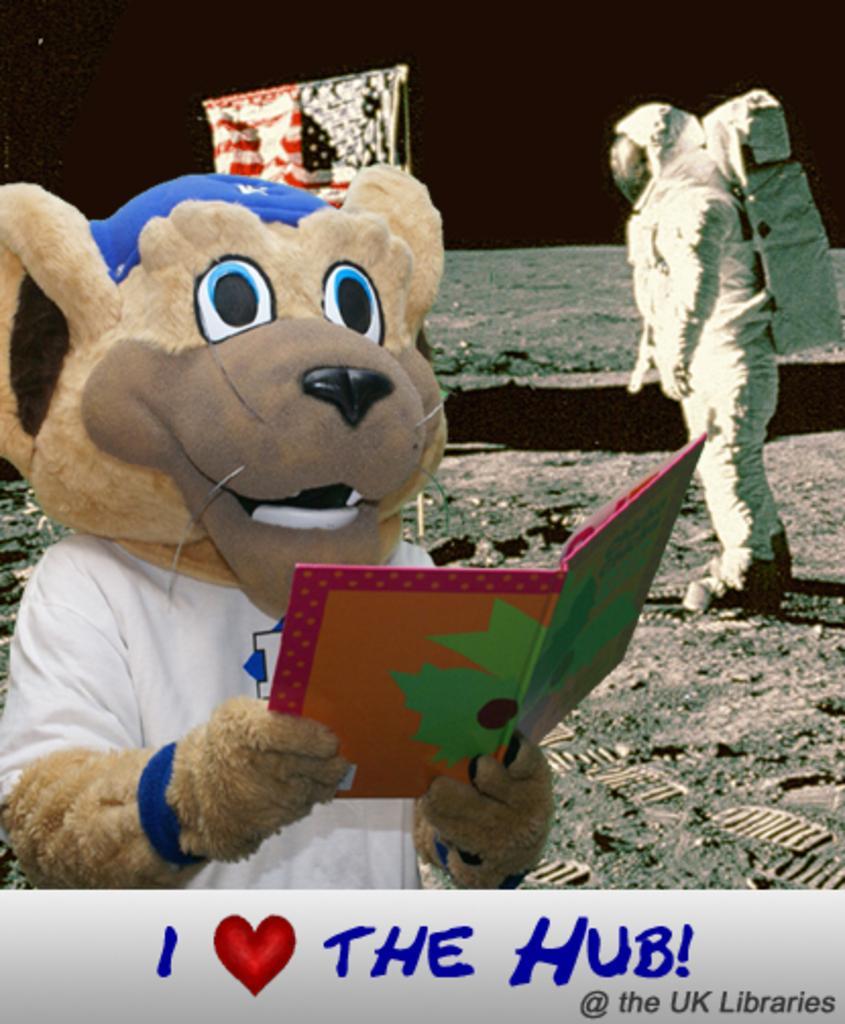Could you give a brief overview of what you see in this image? In this image we can see a person wearing stuffed animal costume and holding a book in his hands. Here we can see a person wearing space suit, we can see shoe prints and the flag here. The background of the image is dark. Here we can see some edited text. 